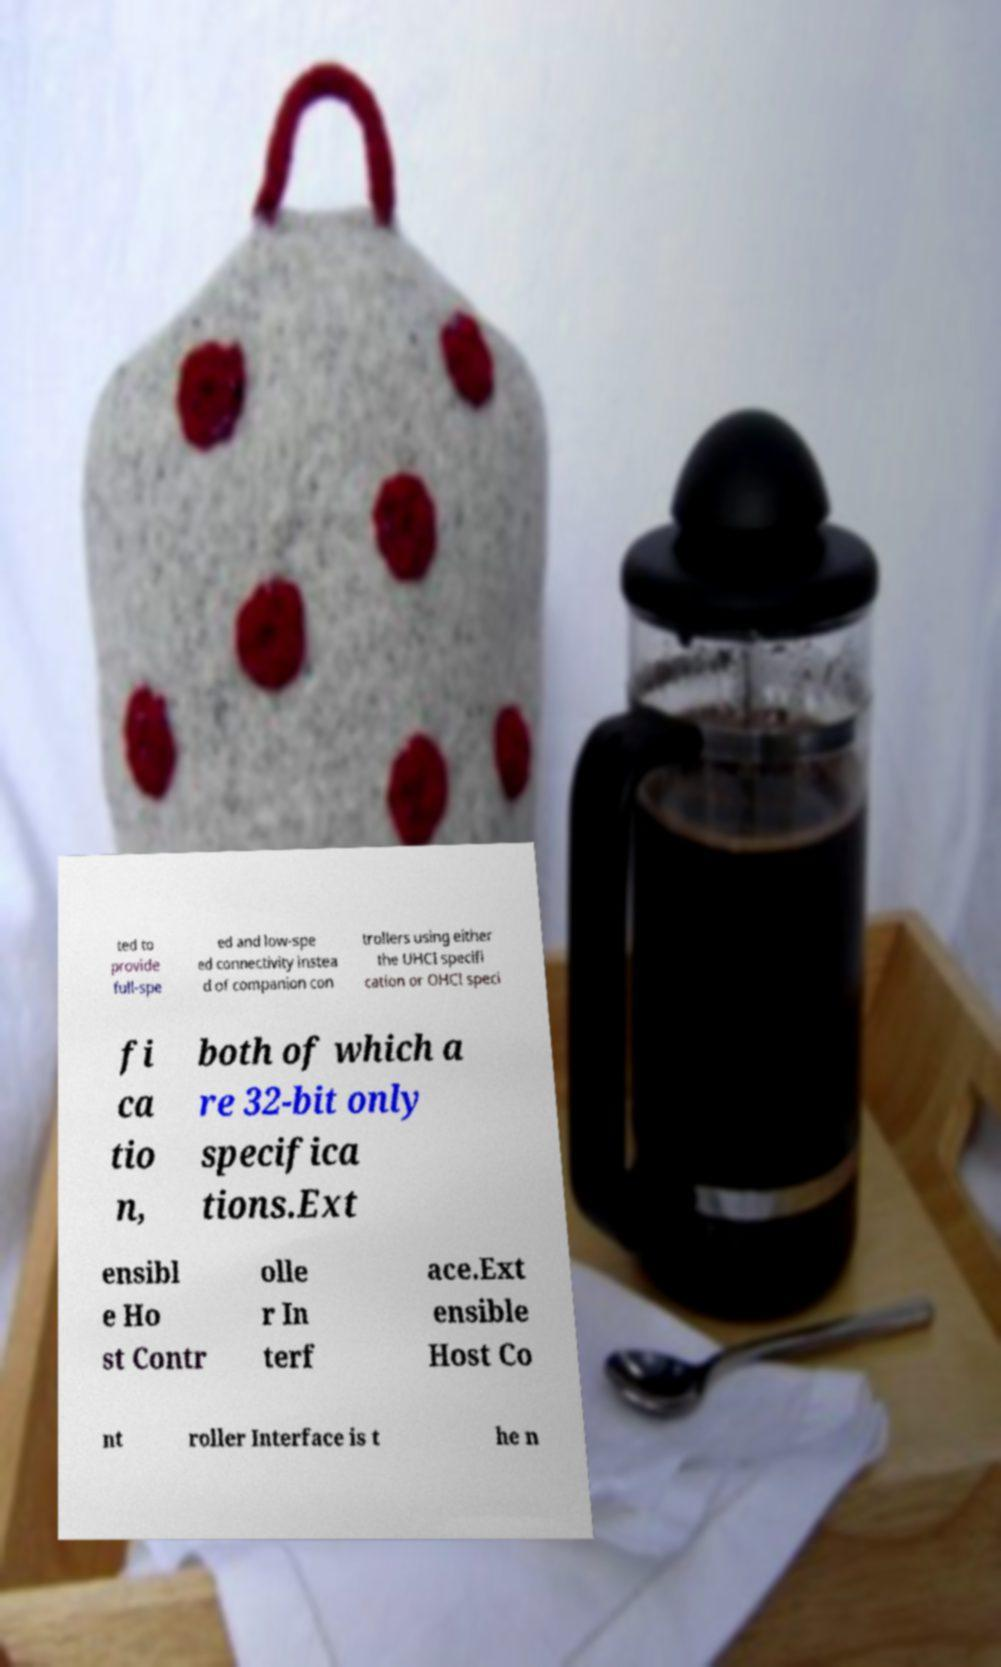Could you extract and type out the text from this image? ted to provide full-spe ed and low-spe ed connectivity instea d of companion con trollers using either the UHCI specifi cation or OHCI speci fi ca tio n, both of which a re 32-bit only specifica tions.Ext ensibl e Ho st Contr olle r In terf ace.Ext ensible Host Co nt roller Interface is t he n 